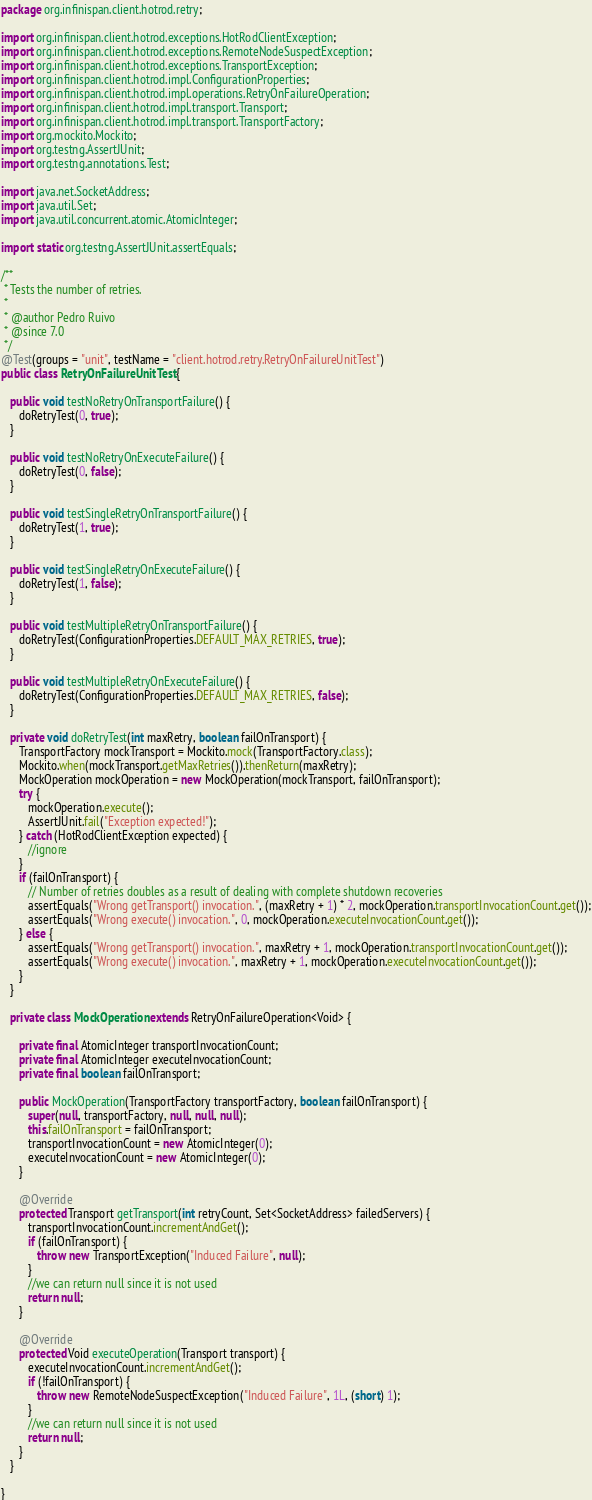Convert code to text. <code><loc_0><loc_0><loc_500><loc_500><_Java_>package org.infinispan.client.hotrod.retry;

import org.infinispan.client.hotrod.exceptions.HotRodClientException;
import org.infinispan.client.hotrod.exceptions.RemoteNodeSuspectException;
import org.infinispan.client.hotrod.exceptions.TransportException;
import org.infinispan.client.hotrod.impl.ConfigurationProperties;
import org.infinispan.client.hotrod.impl.operations.RetryOnFailureOperation;
import org.infinispan.client.hotrod.impl.transport.Transport;
import org.infinispan.client.hotrod.impl.transport.TransportFactory;
import org.mockito.Mockito;
import org.testng.AssertJUnit;
import org.testng.annotations.Test;

import java.net.SocketAddress;
import java.util.Set;
import java.util.concurrent.atomic.AtomicInteger;

import static org.testng.AssertJUnit.assertEquals;

/**
 * Tests the number of retries.
 *
 * @author Pedro Ruivo
 * @since 7.0
 */
@Test(groups = "unit", testName = "client.hotrod.retry.RetryOnFailureUnitTest")
public class RetryOnFailureUnitTest {

   public void testNoRetryOnTransportFailure() {
      doRetryTest(0, true);
   }

   public void testNoRetryOnExecuteFailure() {
      doRetryTest(0, false);
   }

   public void testSingleRetryOnTransportFailure() {
      doRetryTest(1, true);
   }

   public void testSingleRetryOnExecuteFailure() {
      doRetryTest(1, false);
   }

   public void testMultipleRetryOnTransportFailure() {
      doRetryTest(ConfigurationProperties.DEFAULT_MAX_RETRIES, true);
   }

   public void testMultipleRetryOnExecuteFailure() {
      doRetryTest(ConfigurationProperties.DEFAULT_MAX_RETRIES, false);
   }

   private void doRetryTest(int maxRetry, boolean failOnTransport) {
      TransportFactory mockTransport = Mockito.mock(TransportFactory.class);
      Mockito.when(mockTransport.getMaxRetries()).thenReturn(maxRetry);
      MockOperation mockOperation = new MockOperation(mockTransport, failOnTransport);
      try {
         mockOperation.execute();
         AssertJUnit.fail("Exception expected!");
      } catch (HotRodClientException expected) {
         //ignore
      }
      if (failOnTransport) {
         // Number of retries doubles as a result of dealing with complete shutdown recoveries
         assertEquals("Wrong getTransport() invocation.", (maxRetry + 1) * 2, mockOperation.transportInvocationCount.get());
         assertEquals("Wrong execute() invocation.", 0, mockOperation.executeInvocationCount.get());
      } else {
         assertEquals("Wrong getTransport() invocation.", maxRetry + 1, mockOperation.transportInvocationCount.get());
         assertEquals("Wrong execute() invocation.", maxRetry + 1, mockOperation.executeInvocationCount.get());
      }
   }

   private class MockOperation extends RetryOnFailureOperation<Void> {

      private final AtomicInteger transportInvocationCount;
      private final AtomicInteger executeInvocationCount;
      private final boolean failOnTransport;

      public MockOperation(TransportFactory transportFactory, boolean failOnTransport) {
         super(null, transportFactory, null, null, null);
         this.failOnTransport = failOnTransport;
         transportInvocationCount = new AtomicInteger(0);
         executeInvocationCount = new AtomicInteger(0);
      }

      @Override
      protected Transport getTransport(int retryCount, Set<SocketAddress> failedServers) {
         transportInvocationCount.incrementAndGet();
         if (failOnTransport) {
            throw new TransportException("Induced Failure", null);
         }
         //we can return null since it is not used
         return null;
      }

      @Override
      protected Void executeOperation(Transport transport) {
         executeInvocationCount.incrementAndGet();
         if (!failOnTransport) {
            throw new RemoteNodeSuspectException("Induced Failure", 1L, (short) 1);
         }
         //we can return null since it is not used
         return null;
      }
   }

}
</code> 